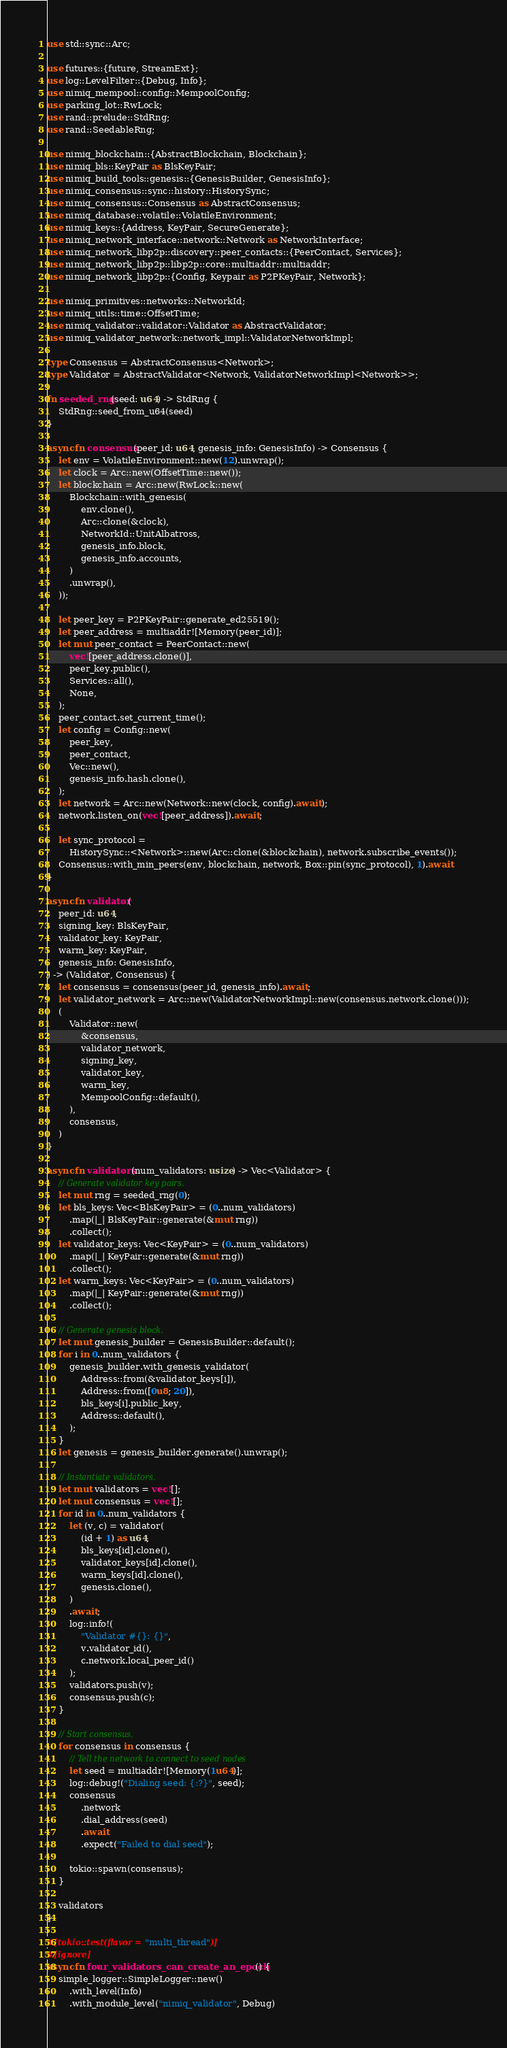Convert code to text. <code><loc_0><loc_0><loc_500><loc_500><_Rust_>use std::sync::Arc;

use futures::{future, StreamExt};
use log::LevelFilter::{Debug, Info};
use nimiq_mempool::config::MempoolConfig;
use parking_lot::RwLock;
use rand::prelude::StdRng;
use rand::SeedableRng;

use nimiq_blockchain::{AbstractBlockchain, Blockchain};
use nimiq_bls::KeyPair as BlsKeyPair;
use nimiq_build_tools::genesis::{GenesisBuilder, GenesisInfo};
use nimiq_consensus::sync::history::HistorySync;
use nimiq_consensus::Consensus as AbstractConsensus;
use nimiq_database::volatile::VolatileEnvironment;
use nimiq_keys::{Address, KeyPair, SecureGenerate};
use nimiq_network_interface::network::Network as NetworkInterface;
use nimiq_network_libp2p::discovery::peer_contacts::{PeerContact, Services};
use nimiq_network_libp2p::libp2p::core::multiaddr::multiaddr;
use nimiq_network_libp2p::{Config, Keypair as P2PKeyPair, Network};

use nimiq_primitives::networks::NetworkId;
use nimiq_utils::time::OffsetTime;
use nimiq_validator::validator::Validator as AbstractValidator;
use nimiq_validator_network::network_impl::ValidatorNetworkImpl;

type Consensus = AbstractConsensus<Network>;
type Validator = AbstractValidator<Network, ValidatorNetworkImpl<Network>>;

fn seeded_rng(seed: u64) -> StdRng {
    StdRng::seed_from_u64(seed)
}

async fn consensus(peer_id: u64, genesis_info: GenesisInfo) -> Consensus {
    let env = VolatileEnvironment::new(12).unwrap();
    let clock = Arc::new(OffsetTime::new());
    let blockchain = Arc::new(RwLock::new(
        Blockchain::with_genesis(
            env.clone(),
            Arc::clone(&clock),
            NetworkId::UnitAlbatross,
            genesis_info.block,
            genesis_info.accounts,
        )
        .unwrap(),
    ));

    let peer_key = P2PKeyPair::generate_ed25519();
    let peer_address = multiaddr![Memory(peer_id)];
    let mut peer_contact = PeerContact::new(
        vec![peer_address.clone()],
        peer_key.public(),
        Services::all(),
        None,
    );
    peer_contact.set_current_time();
    let config = Config::new(
        peer_key,
        peer_contact,
        Vec::new(),
        genesis_info.hash.clone(),
    );
    let network = Arc::new(Network::new(clock, config).await);
    network.listen_on(vec![peer_address]).await;

    let sync_protocol =
        HistorySync::<Network>::new(Arc::clone(&blockchain), network.subscribe_events());
    Consensus::with_min_peers(env, blockchain, network, Box::pin(sync_protocol), 1).await
}

async fn validator(
    peer_id: u64,
    signing_key: BlsKeyPair,
    validator_key: KeyPair,
    warm_key: KeyPair,
    genesis_info: GenesisInfo,
) -> (Validator, Consensus) {
    let consensus = consensus(peer_id, genesis_info).await;
    let validator_network = Arc::new(ValidatorNetworkImpl::new(consensus.network.clone()));
    (
        Validator::new(
            &consensus,
            validator_network,
            signing_key,
            validator_key,
            warm_key,
            MempoolConfig::default(),
        ),
        consensus,
    )
}

async fn validators(num_validators: usize) -> Vec<Validator> {
    // Generate validator key pairs.
    let mut rng = seeded_rng(0);
    let bls_keys: Vec<BlsKeyPair> = (0..num_validators)
        .map(|_| BlsKeyPair::generate(&mut rng))
        .collect();
    let validator_keys: Vec<KeyPair> = (0..num_validators)
        .map(|_| KeyPair::generate(&mut rng))
        .collect();
    let warm_keys: Vec<KeyPair> = (0..num_validators)
        .map(|_| KeyPair::generate(&mut rng))
        .collect();

    // Generate genesis block.
    let mut genesis_builder = GenesisBuilder::default();
    for i in 0..num_validators {
        genesis_builder.with_genesis_validator(
            Address::from(&validator_keys[i]),
            Address::from([0u8; 20]),
            bls_keys[i].public_key,
            Address::default(),
        );
    }
    let genesis = genesis_builder.generate().unwrap();

    // Instantiate validators.
    let mut validators = vec![];
    let mut consensus = vec![];
    for id in 0..num_validators {
        let (v, c) = validator(
            (id + 1) as u64,
            bls_keys[id].clone(),
            validator_keys[id].clone(),
            warm_keys[id].clone(),
            genesis.clone(),
        )
        .await;
        log::info!(
            "Validator #{}: {}",
            v.validator_id(),
            c.network.local_peer_id()
        );
        validators.push(v);
        consensus.push(c);
    }

    // Start consensus.
    for consensus in consensus {
        // Tell the network to connect to seed nodes
        let seed = multiaddr![Memory(1u64)];
        log::debug!("Dialing seed: {:?}", seed);
        consensus
            .network
            .dial_address(seed)
            .await
            .expect("Failed to dial seed");

        tokio::spawn(consensus);
    }

    validators
}

#[tokio::test(flavor = "multi_thread")]
#[ignore]
async fn four_validators_can_create_an_epoch() {
    simple_logger::SimpleLogger::new()
        .with_level(Info)
        .with_module_level("nimiq_validator", Debug)</code> 